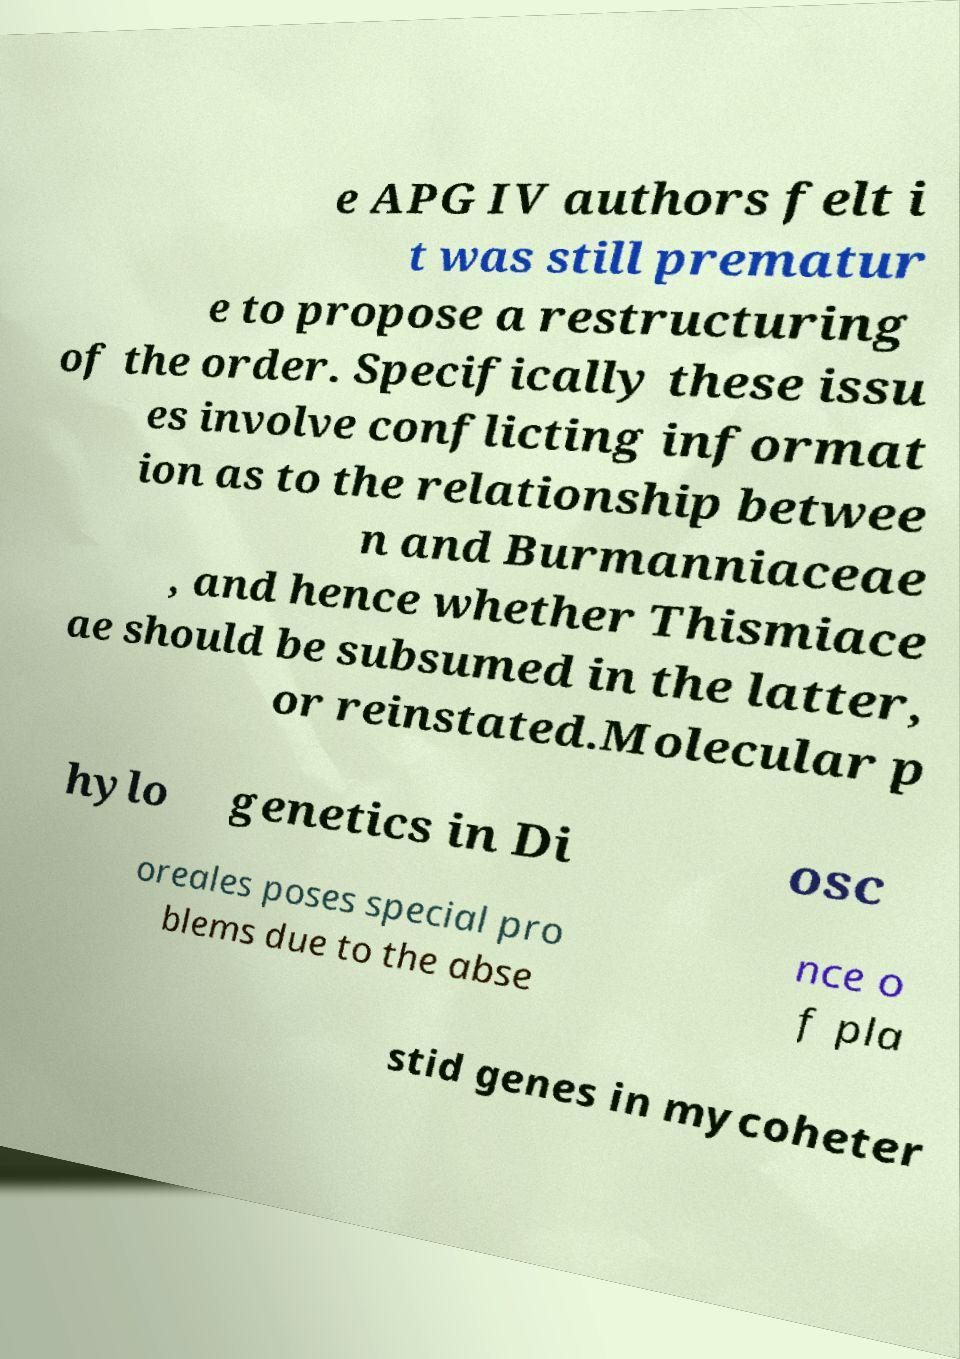Could you assist in decoding the text presented in this image and type it out clearly? e APG IV authors felt i t was still prematur e to propose a restructuring of the order. Specifically these issu es involve conflicting informat ion as to the relationship betwee n and Burmanniaceae , and hence whether Thismiace ae should be subsumed in the latter, or reinstated.Molecular p hylo genetics in Di osc oreales poses special pro blems due to the abse nce o f pla stid genes in mycoheter 